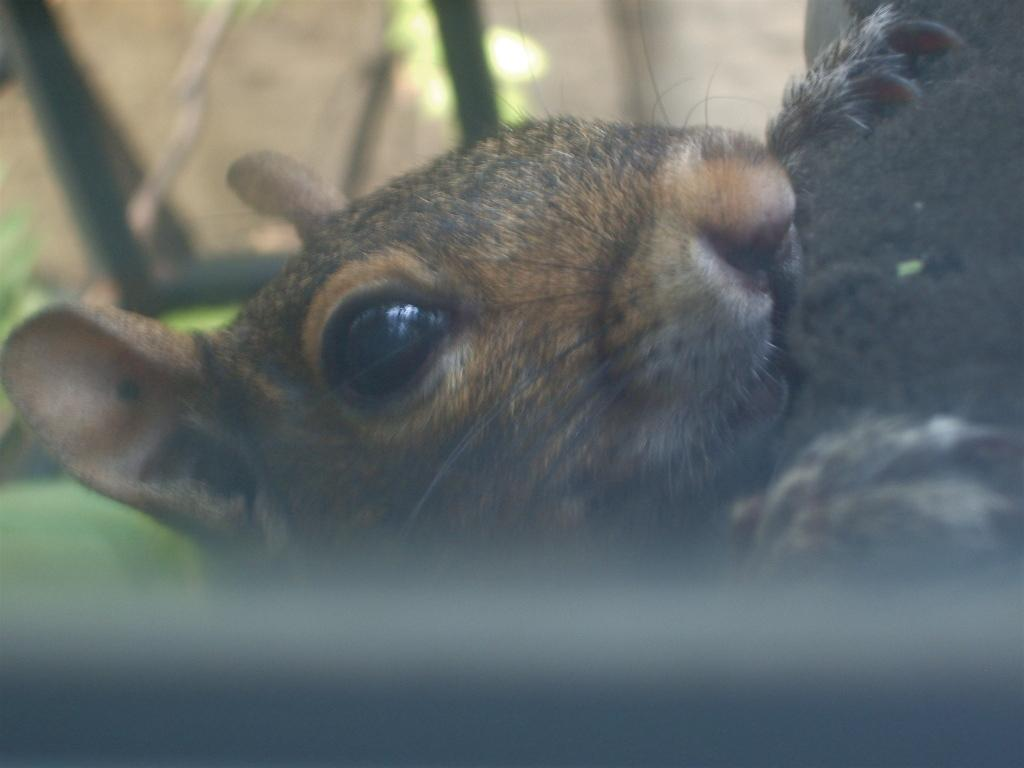What is the main subject of the image? The main subject of the image is a rat's face. What features can be seen on the rat's face? The rat's face has eyes, ears, and a nose. What body parts does the rat have in the image? The rat has two hands with nails. What can be seen in the background of the image? There are plants visible in the background, but they are not clearly visible. Is the rat in the image using paint to create a masterpiece? There is no paint or indication of painting activity in the image; it features a rat's face with its features and hands. 